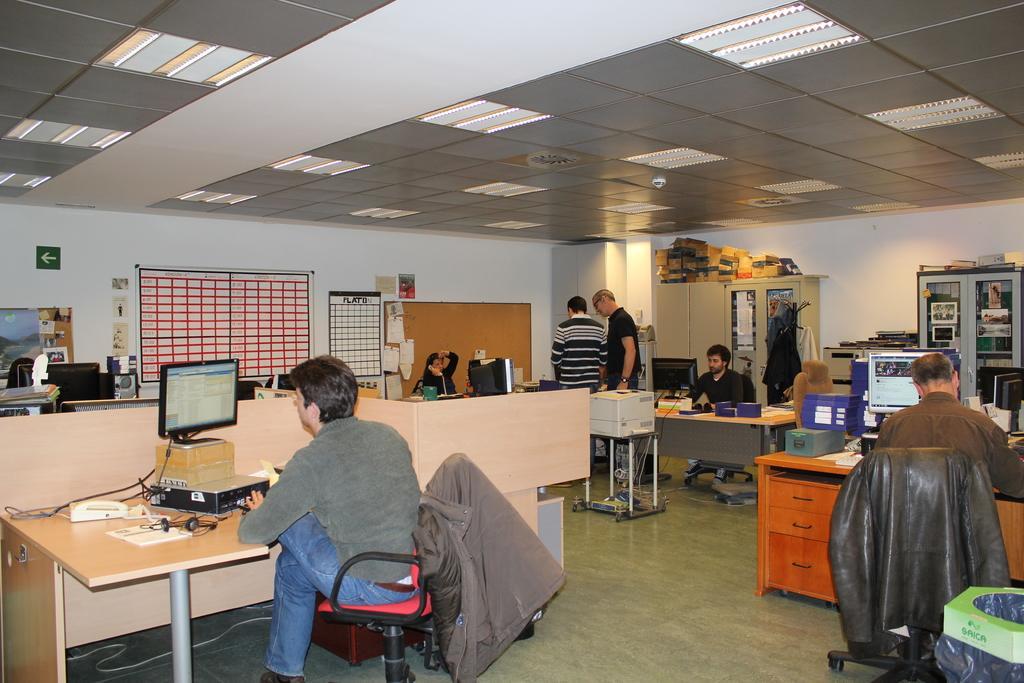Describe this image in one or two sentences. In this picture there are three men who are sitting on the chair. There is a jacket on the chair. There is a computer, phone, headset,paper on the table. There is a woman sitting on the chair and holding a phone in her hand. There is an arrow sign on the wall. There are two men who are standing at the corner. There is a cupboard and few boxes on the cupboard. There is a box in green color on the chair. There is a wire on the ground. 